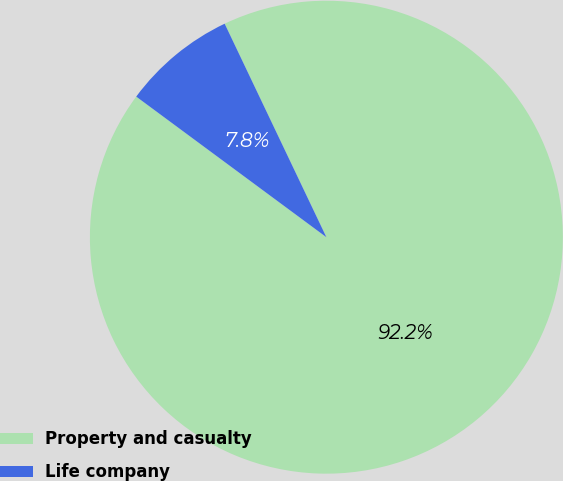Convert chart to OTSL. <chart><loc_0><loc_0><loc_500><loc_500><pie_chart><fcel>Property and casualty<fcel>Life company<nl><fcel>92.21%<fcel>7.79%<nl></chart> 